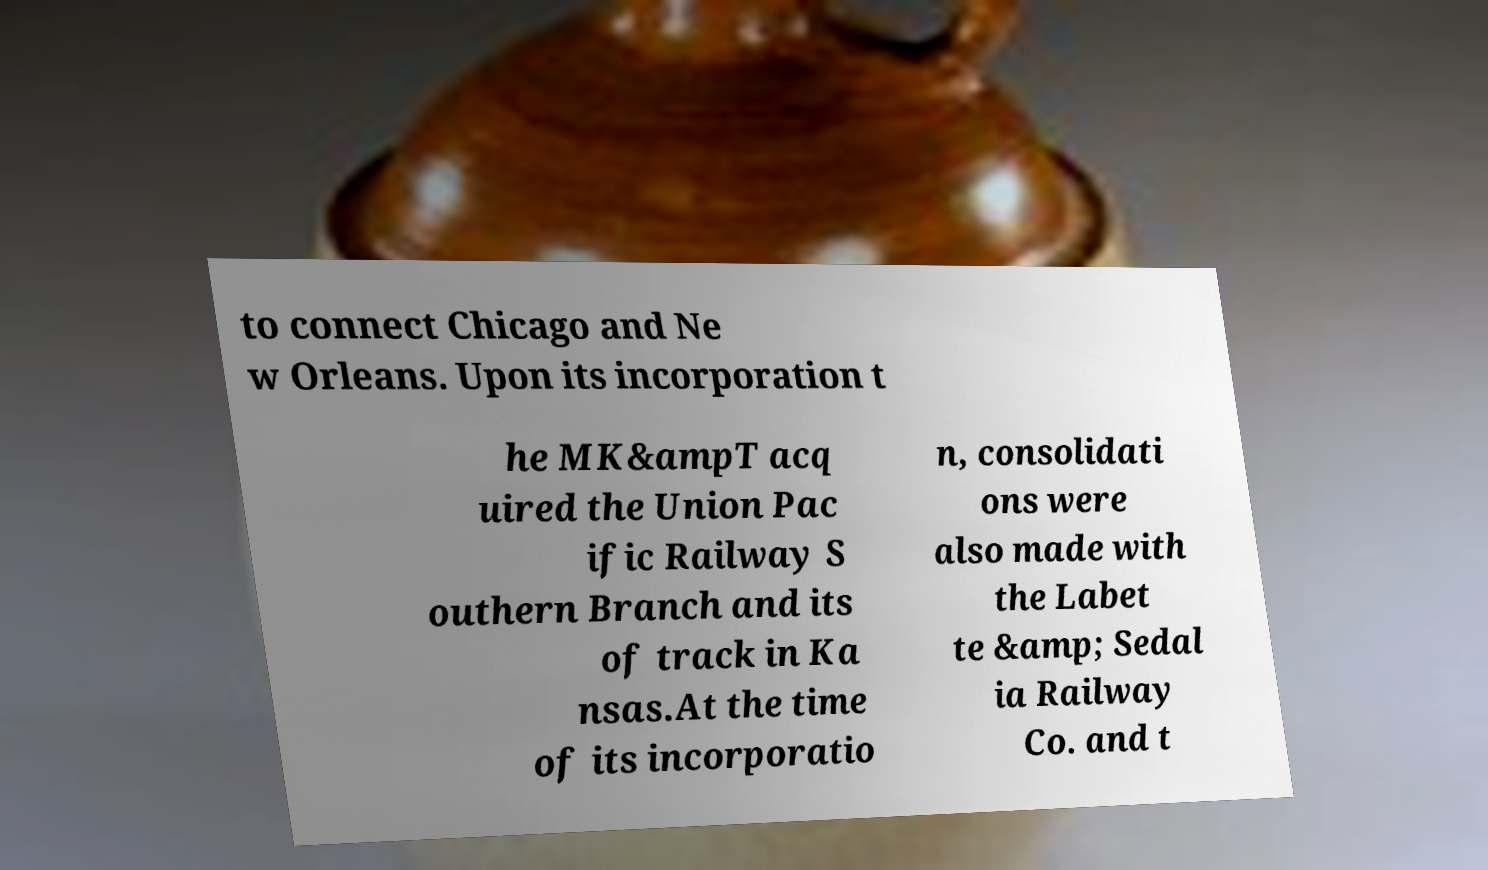Can you accurately transcribe the text from the provided image for me? to connect Chicago and Ne w Orleans. Upon its incorporation t he MK&ampT acq uired the Union Pac ific Railway S outhern Branch and its of track in Ka nsas.At the time of its incorporatio n, consolidati ons were also made with the Labet te &amp; Sedal ia Railway Co. and t 